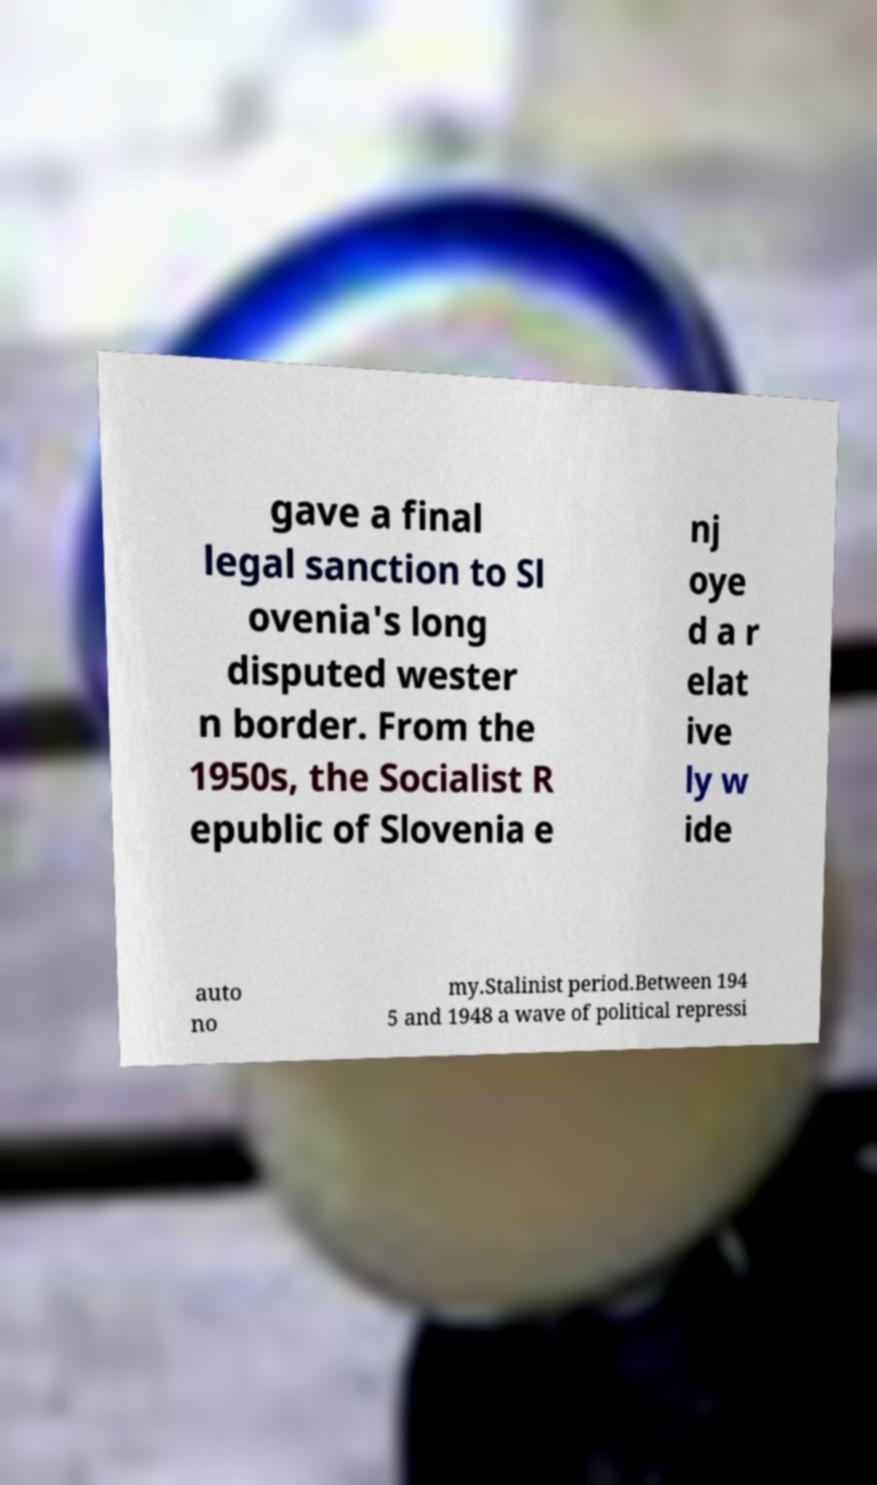For documentation purposes, I need the text within this image transcribed. Could you provide that? gave a final legal sanction to Sl ovenia's long disputed wester n border. From the 1950s, the Socialist R epublic of Slovenia e nj oye d a r elat ive ly w ide auto no my.Stalinist period.Between 194 5 and 1948 a wave of political repressi 